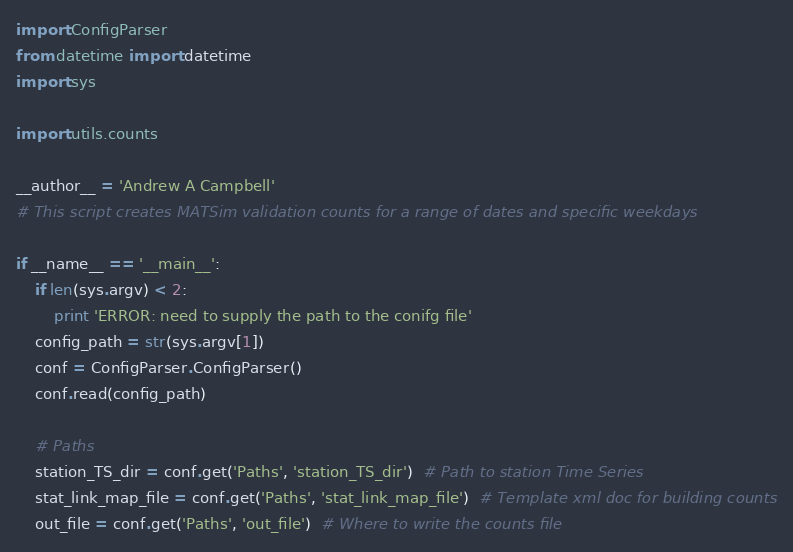<code> <loc_0><loc_0><loc_500><loc_500><_Python_>import ConfigParser
from datetime import datetime
import sys

import utils.counts

__author__ = 'Andrew A Campbell'
# This script creates MATSim validation counts for a range of dates and specific weekdays

if __name__ == '__main__':
    if len(sys.argv) < 2:
        print 'ERROR: need to supply the path to the conifg file'
    config_path = str(sys.argv[1])
    conf = ConfigParser.ConfigParser()
    conf.read(config_path)

    # Paths
    station_TS_dir = conf.get('Paths', 'station_TS_dir')  # Path to station Time Series
    stat_link_map_file = conf.get('Paths', 'stat_link_map_file')  # Template xml doc for building counts
    out_file = conf.get('Paths', 'out_file')  # Where to write the counts file</code> 